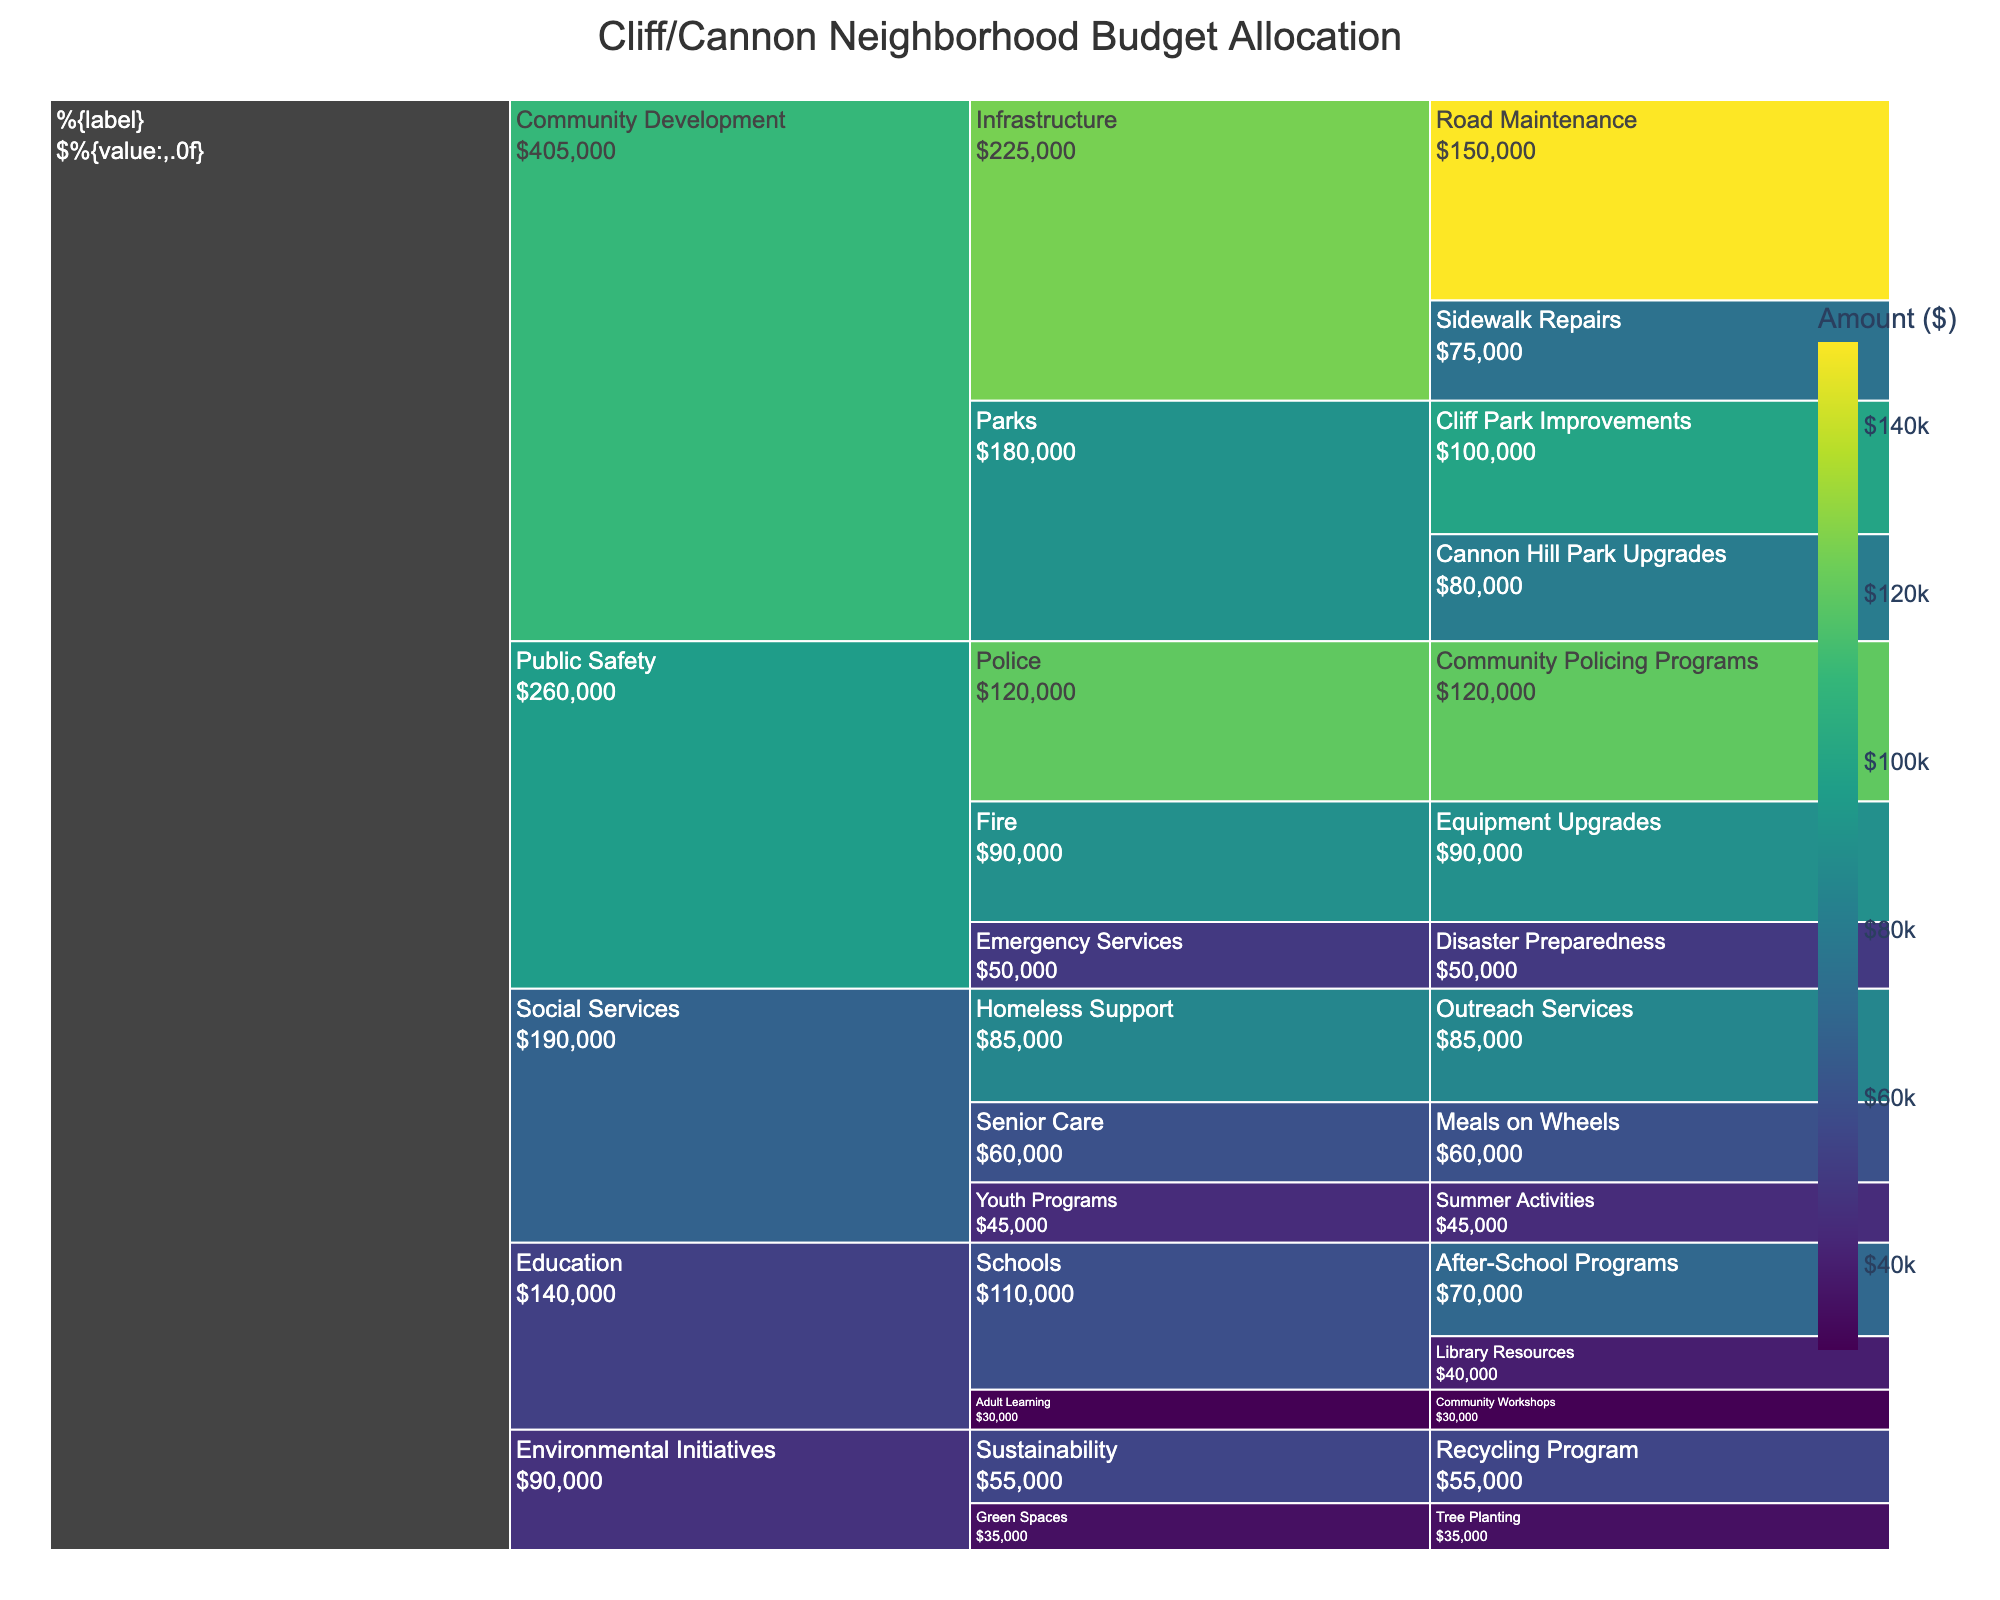what is the total amount allocated to Community Development projects? Sum up the amounts under the Community Development category: Road Maintenance ($150,000), Sidewalk Repairs ($75,000), Cliff Park Improvements ($100,000), Cannon Hill Park Upgrades ($80,000). The total is $150,000 + $75,000 + $100,000 + $80,000 = $405,000
Answer: $405,000 which subcategory within Public Safety received the highest allocation? Compare the amounts allocated to Police ($120,000), Fire ($90,000), and Emergency Services ($50,000). The highest allocation is $120,000 for Police
Answer: Police what is the difference in budget allocation between Education and Environmental Initiatives? First, sum the amounts under Education: After-School Programs ($70,000), Library Resources ($40,000), Community Workshops ($30,000). The total is $70,000 + $40,000 + $30,000 = $140,000. For Environmental Initiatives: Recycling Program ($55,000), Tree Planting ($35,000). The total is $55,000 + $35,000 = $90,000. The difference is $140,000 - $90,000 = $50,000
Answer: $50,000 what is the average budget allocated per project in Social Services? Sum up the amounts for Social Services (Meals on Wheels $60,000, Summer Activities $45,000, Outreach Services $85,000): $60,000 + $45,000 + $85,000 = $190,000. There are three projects, so the average is $190,000 / 3 = $63,333.33
Answer: $63,333.33 how much more is allocated to Community Development compared to Public Safety? First, determine the sum for each category. Community Development: $405,000. Public Safety: Police ($120,000), Fire ($90,000), Emergency Services ($50,000). The total for Public Safety is $120,000 + $90,000 + $50,000 = $260,000. The difference is $405,000 - $260,000 = $145,000
Answer: $145,000 which project received the smallest allocation and how much was it? Compare the allocation amounts for all projects. The smallest allocation is for Tree Planting under Environmental Initiatives, which is $35,000
Answer: Tree Planting, $35,000 